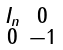Convert formula to latex. <formula><loc_0><loc_0><loc_500><loc_500>\begin{smallmatrix} I _ { n } & 0 \\ 0 & - 1 \end{smallmatrix}</formula> 